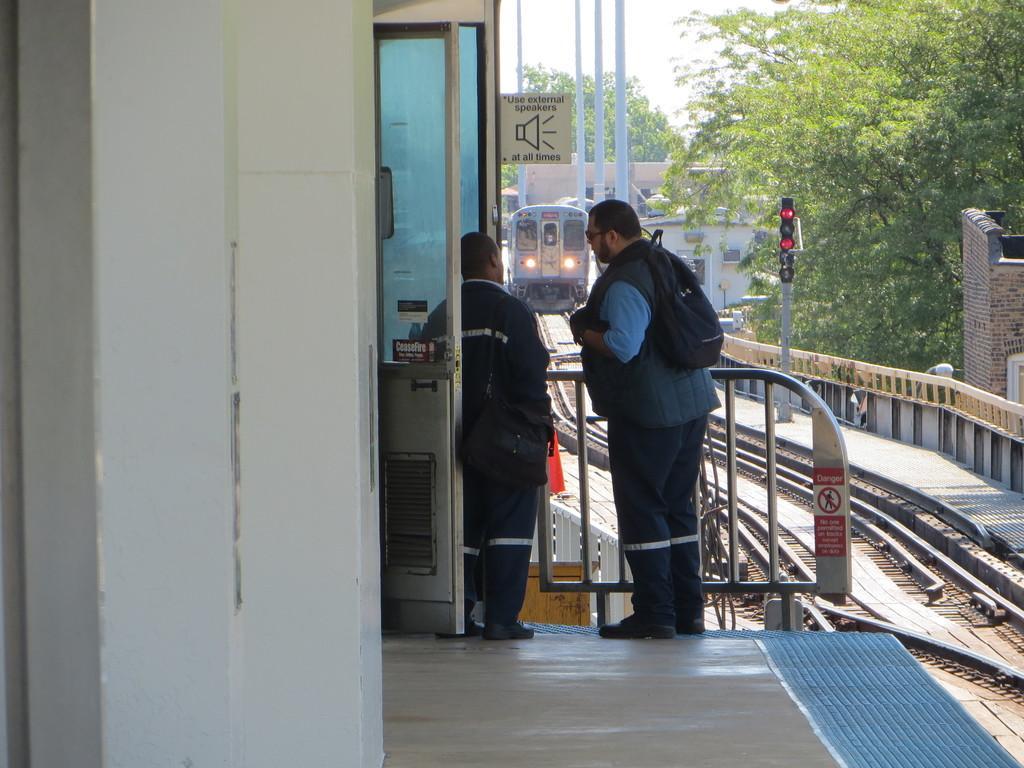In one or two sentences, can you explain what this image depicts? In this image there are two people standing in front of the door. On the right side of the image there is a train on the railway track. There is a signal board. In the background of the image there are trees, buildings and sky. On the left side of the image there is a wall. 